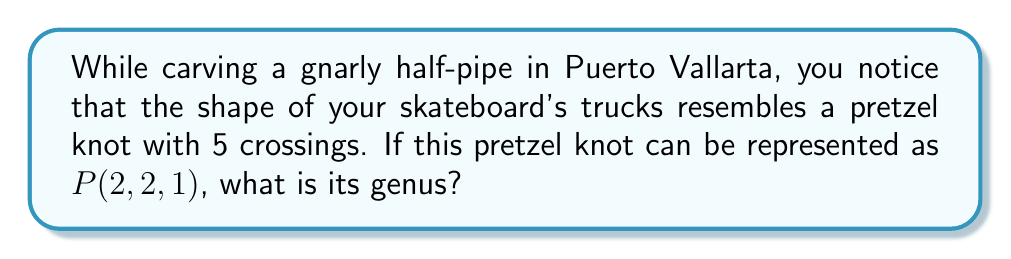What is the answer to this math problem? To find the genus of a pretzel knot $P(p,q,r)$, we can follow these steps:

1) The genus $g$ of a pretzel knot $P(p,q,r)$ is given by the formula:

   $$g = \frac{1}{2}(|p| + |q| + |r| - 1)$$

   where $|p|$, $|q|$, and $|r|$ represent the absolute values of $p$, $q$, and $r$ respectively.

2) In this case, we have $P(2,2,1)$, so:
   $p = 2$, $q = 2$, $r = 1$

3) Substituting these values into the formula:

   $$g = \frac{1}{2}(|2| + |2| + |1| - 1)$$

4) Simplify:
   $$g = \frac{1}{2}(2 + 2 + 1 - 1)$$
   $$g = \frac{1}{2}(4)$$

5) Calculate the final result:
   $$g = 2$$

Therefore, the genus of the pretzel knot $P(2,2,1)$ is 2.
Answer: 2 